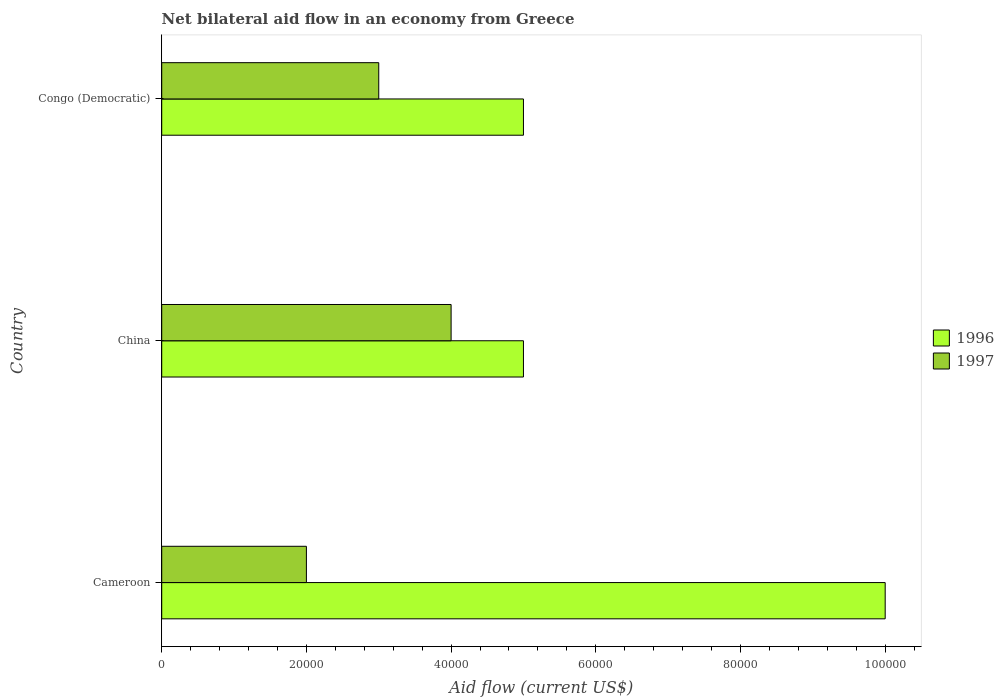How many groups of bars are there?
Give a very brief answer. 3. Are the number of bars per tick equal to the number of legend labels?
Provide a short and direct response. Yes. How many bars are there on the 1st tick from the top?
Make the answer very short. 2. How many bars are there on the 3rd tick from the bottom?
Offer a terse response. 2. What is the label of the 2nd group of bars from the top?
Your answer should be very brief. China. In how many cases, is the number of bars for a given country not equal to the number of legend labels?
Offer a terse response. 0. Across all countries, what is the minimum net bilateral aid flow in 1997?
Offer a very short reply. 2.00e+04. In which country was the net bilateral aid flow in 1996 maximum?
Offer a very short reply. Cameroon. What is the total net bilateral aid flow in 1996 in the graph?
Give a very brief answer. 2.00e+05. What is the difference between the net bilateral aid flow in 1997 in Cameroon and that in Congo (Democratic)?
Your response must be concise. -10000. What is the difference between the net bilateral aid flow in 1996 in Cameroon and the net bilateral aid flow in 1997 in Congo (Democratic)?
Offer a terse response. 7.00e+04. What is the average net bilateral aid flow in 1997 per country?
Offer a very short reply. 3.00e+04. What is the difference between the net bilateral aid flow in 1997 and net bilateral aid flow in 1996 in Congo (Democratic)?
Ensure brevity in your answer.  -2.00e+04. In how many countries, is the net bilateral aid flow in 1996 greater than 12000 US$?
Your answer should be very brief. 3. Is the difference between the net bilateral aid flow in 1997 in China and Congo (Democratic) greater than the difference between the net bilateral aid flow in 1996 in China and Congo (Democratic)?
Make the answer very short. Yes. What is the difference between the highest and the second highest net bilateral aid flow in 1996?
Offer a terse response. 5.00e+04. What is the difference between the highest and the lowest net bilateral aid flow in 1997?
Keep it short and to the point. 2.00e+04. Are all the bars in the graph horizontal?
Offer a very short reply. Yes. How many countries are there in the graph?
Make the answer very short. 3. Are the values on the major ticks of X-axis written in scientific E-notation?
Make the answer very short. No. Does the graph contain any zero values?
Give a very brief answer. No. Does the graph contain grids?
Offer a terse response. No. Where does the legend appear in the graph?
Ensure brevity in your answer.  Center right. How many legend labels are there?
Your answer should be very brief. 2. How are the legend labels stacked?
Provide a succinct answer. Vertical. What is the title of the graph?
Make the answer very short. Net bilateral aid flow in an economy from Greece. Does "1976" appear as one of the legend labels in the graph?
Offer a very short reply. No. What is the label or title of the Y-axis?
Offer a terse response. Country. What is the Aid flow (current US$) in 1997 in China?
Provide a short and direct response. 4.00e+04. What is the Aid flow (current US$) in 1996 in Congo (Democratic)?
Make the answer very short. 5.00e+04. Across all countries, what is the maximum Aid flow (current US$) of 1996?
Make the answer very short. 1.00e+05. Across all countries, what is the maximum Aid flow (current US$) of 1997?
Offer a terse response. 4.00e+04. What is the total Aid flow (current US$) in 1996 in the graph?
Keep it short and to the point. 2.00e+05. What is the total Aid flow (current US$) in 1997 in the graph?
Offer a very short reply. 9.00e+04. What is the difference between the Aid flow (current US$) in 1996 in Cameroon and that in China?
Your answer should be compact. 5.00e+04. What is the difference between the Aid flow (current US$) of 1997 in Cameroon and that in China?
Your response must be concise. -2.00e+04. What is the difference between the Aid flow (current US$) in 1997 in China and that in Congo (Democratic)?
Provide a succinct answer. 10000. What is the average Aid flow (current US$) of 1996 per country?
Ensure brevity in your answer.  6.67e+04. What is the average Aid flow (current US$) in 1997 per country?
Make the answer very short. 3.00e+04. What is the ratio of the Aid flow (current US$) of 1996 in Cameroon to that in China?
Make the answer very short. 2. What is the ratio of the Aid flow (current US$) of 1997 in Cameroon to that in China?
Keep it short and to the point. 0.5. What is the ratio of the Aid flow (current US$) in 1996 in Cameroon to that in Congo (Democratic)?
Provide a short and direct response. 2. What is the ratio of the Aid flow (current US$) in 1997 in Cameroon to that in Congo (Democratic)?
Your answer should be very brief. 0.67. What is the ratio of the Aid flow (current US$) in 1996 in China to that in Congo (Democratic)?
Offer a terse response. 1. What is the ratio of the Aid flow (current US$) of 1997 in China to that in Congo (Democratic)?
Offer a terse response. 1.33. What is the difference between the highest and the second highest Aid flow (current US$) of 1996?
Offer a very short reply. 5.00e+04. What is the difference between the highest and the lowest Aid flow (current US$) in 1997?
Keep it short and to the point. 2.00e+04. 